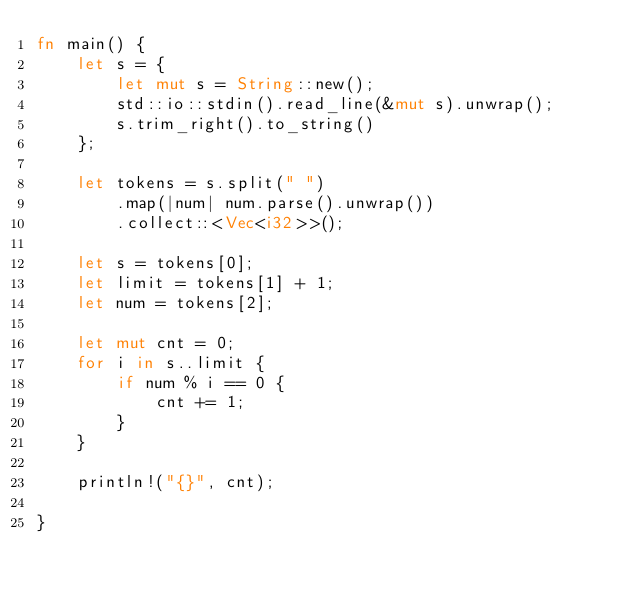<code> <loc_0><loc_0><loc_500><loc_500><_Rust_>fn main() {
    let s = {
        let mut s = String::new(); 
        std::io::stdin().read_line(&mut s).unwrap();
        s.trim_right().to_string()
    };

    let tokens = s.split(" ")
        .map(|num| num.parse().unwrap())
        .collect::<Vec<i32>>();

    let s = tokens[0];
    let limit = tokens[1] + 1;
    let num = tokens[2];

    let mut cnt = 0;
    for i in s..limit {
        if num % i == 0 {
            cnt += 1;
        }
    }

    println!("{}", cnt);

}

</code> 